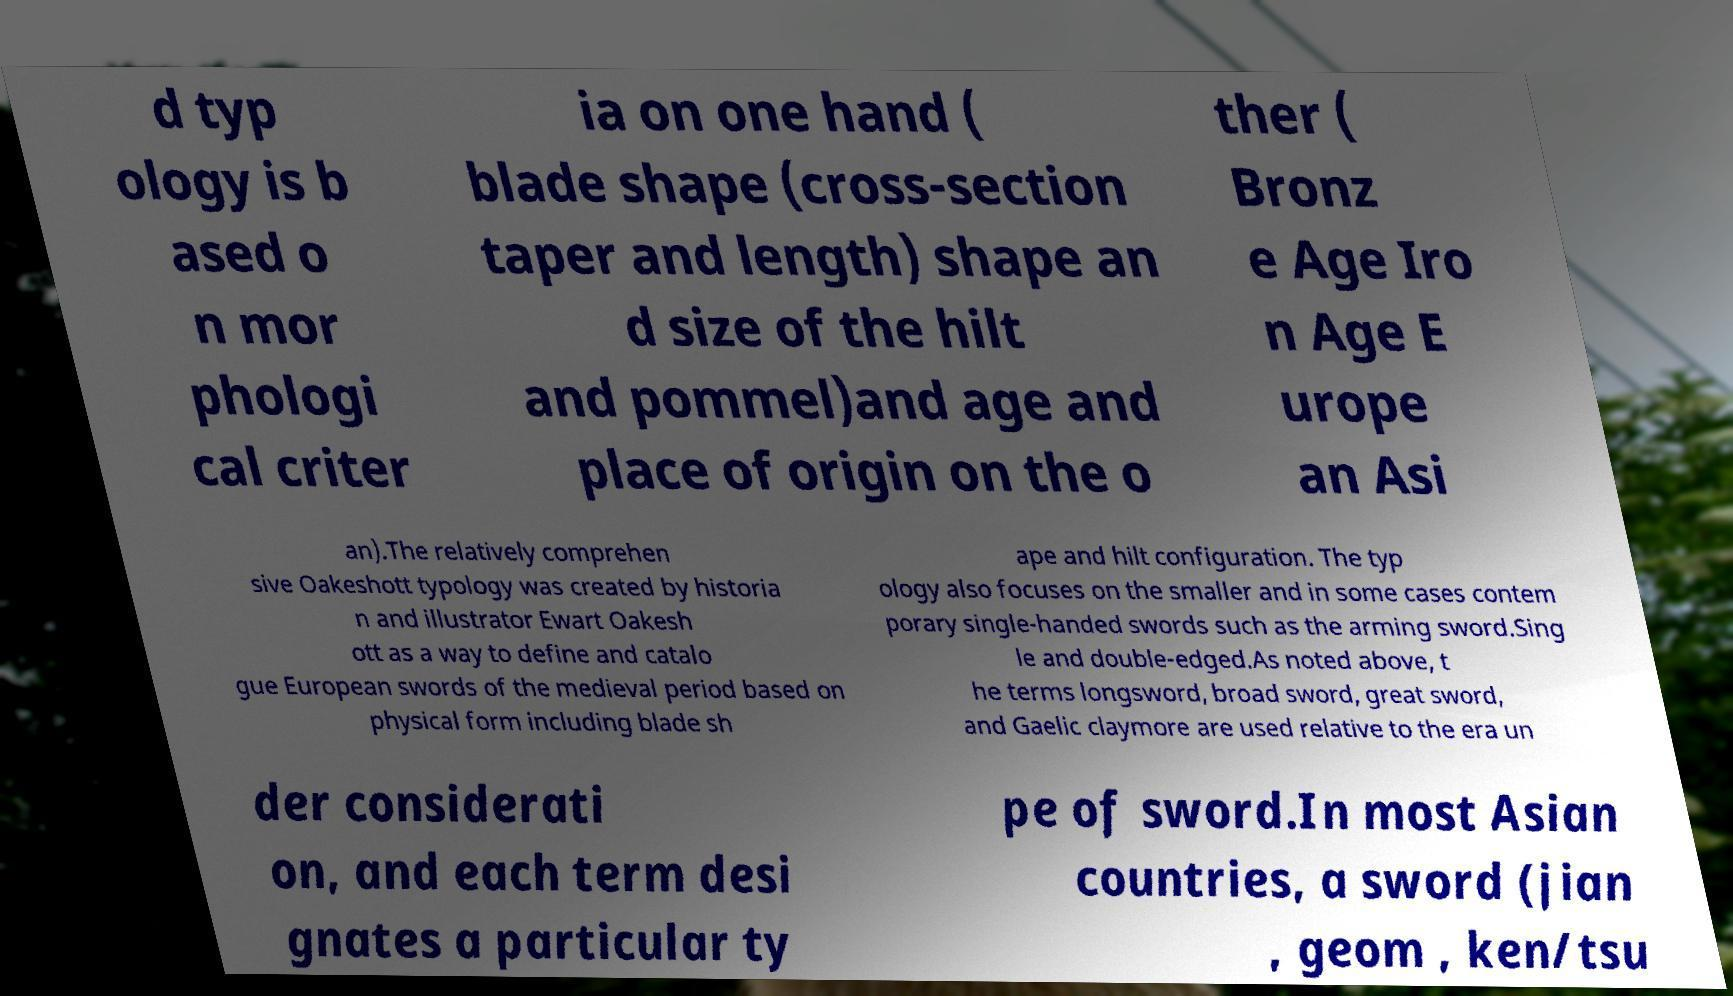I need the written content from this picture converted into text. Can you do that? d typ ology is b ased o n mor phologi cal criter ia on one hand ( blade shape (cross-section taper and length) shape an d size of the hilt and pommel)and age and place of origin on the o ther ( Bronz e Age Iro n Age E urope an Asi an).The relatively comprehen sive Oakeshott typology was created by historia n and illustrator Ewart Oakesh ott as a way to define and catalo gue European swords of the medieval period based on physical form including blade sh ape and hilt configuration. The typ ology also focuses on the smaller and in some cases contem porary single-handed swords such as the arming sword.Sing le and double-edged.As noted above, t he terms longsword, broad sword, great sword, and Gaelic claymore are used relative to the era un der considerati on, and each term desi gnates a particular ty pe of sword.In most Asian countries, a sword (jian , geom , ken/tsu 